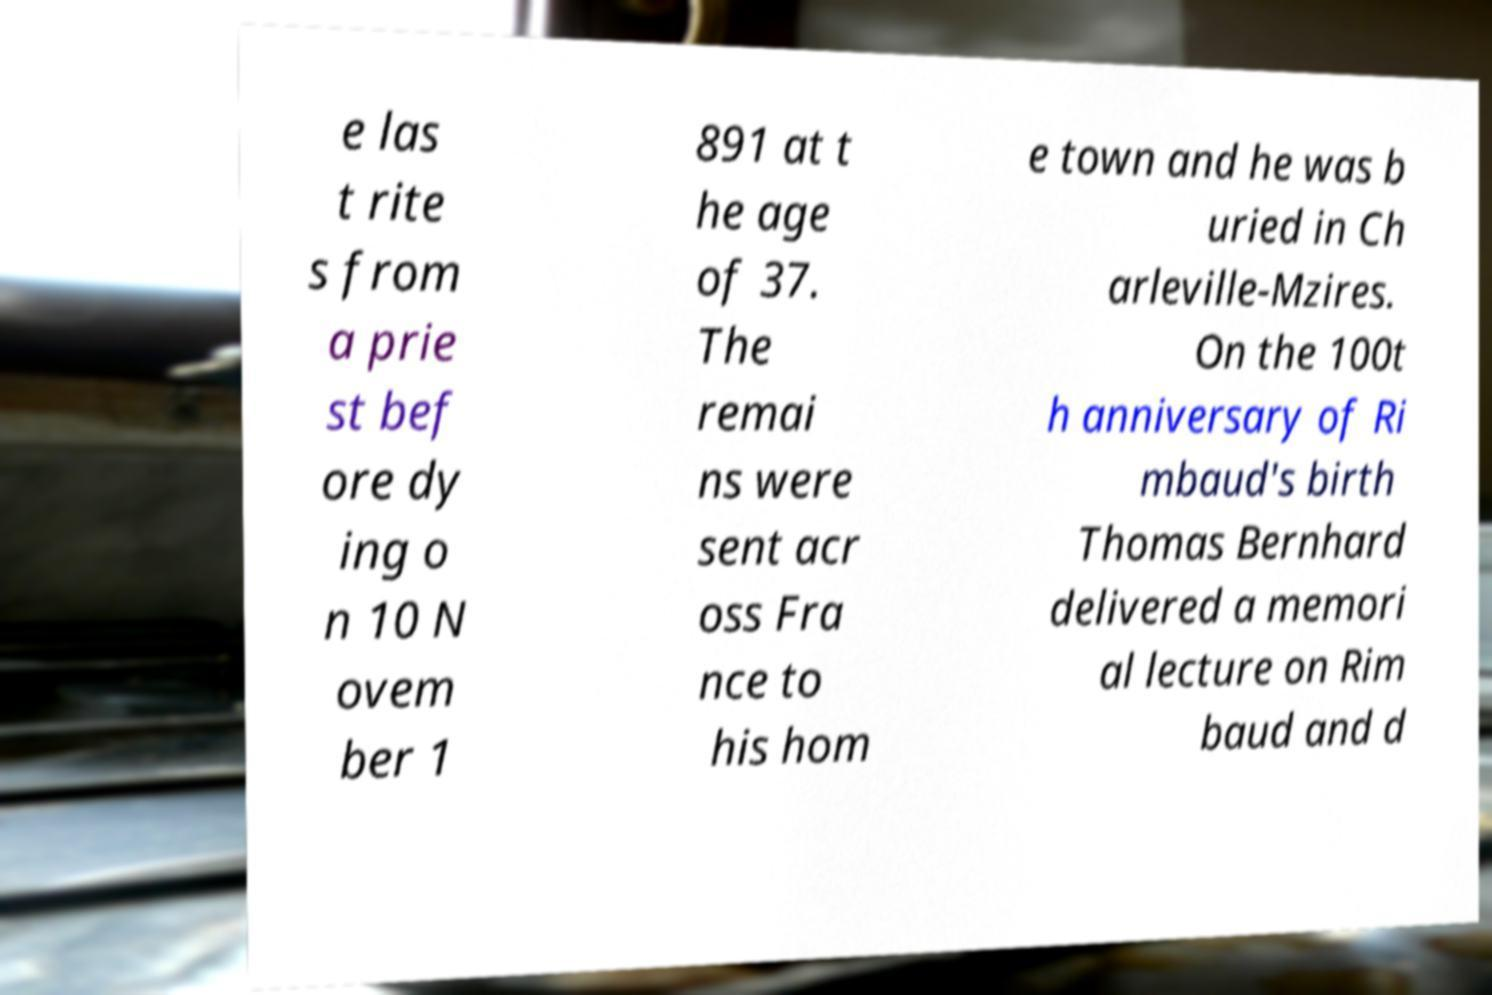I need the written content from this picture converted into text. Can you do that? e las t rite s from a prie st bef ore dy ing o n 10 N ovem ber 1 891 at t he age of 37. The remai ns were sent acr oss Fra nce to his hom e town and he was b uried in Ch arleville-Mzires. On the 100t h anniversary of Ri mbaud's birth Thomas Bernhard delivered a memori al lecture on Rim baud and d 